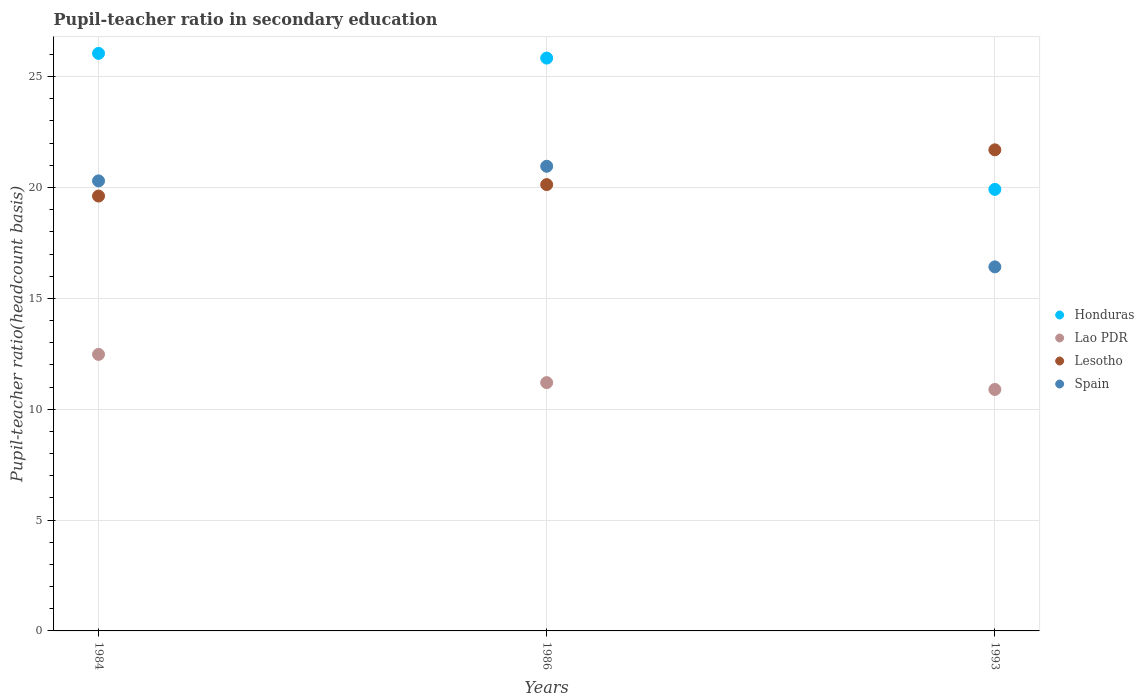How many different coloured dotlines are there?
Make the answer very short. 4. Is the number of dotlines equal to the number of legend labels?
Give a very brief answer. Yes. What is the pupil-teacher ratio in secondary education in Spain in 1984?
Provide a short and direct response. 20.3. Across all years, what is the maximum pupil-teacher ratio in secondary education in Spain?
Make the answer very short. 20.96. Across all years, what is the minimum pupil-teacher ratio in secondary education in Spain?
Offer a terse response. 16.42. In which year was the pupil-teacher ratio in secondary education in Honduras maximum?
Offer a very short reply. 1984. What is the total pupil-teacher ratio in secondary education in Lesotho in the graph?
Give a very brief answer. 61.45. What is the difference between the pupil-teacher ratio in secondary education in Lesotho in 1984 and that in 1986?
Your response must be concise. -0.52. What is the difference between the pupil-teacher ratio in secondary education in Honduras in 1993 and the pupil-teacher ratio in secondary education in Lao PDR in 1986?
Your answer should be compact. 8.72. What is the average pupil-teacher ratio in secondary education in Lao PDR per year?
Offer a very short reply. 11.52. In the year 1993, what is the difference between the pupil-teacher ratio in secondary education in Honduras and pupil-teacher ratio in secondary education in Lao PDR?
Your response must be concise. 9.02. In how many years, is the pupil-teacher ratio in secondary education in Lesotho greater than 18?
Offer a terse response. 3. What is the ratio of the pupil-teacher ratio in secondary education in Honduras in 1984 to that in 1993?
Give a very brief answer. 1.31. Is the pupil-teacher ratio in secondary education in Lao PDR in 1986 less than that in 1993?
Your answer should be compact. No. What is the difference between the highest and the second highest pupil-teacher ratio in secondary education in Honduras?
Give a very brief answer. 0.21. What is the difference between the highest and the lowest pupil-teacher ratio in secondary education in Spain?
Ensure brevity in your answer.  4.54. In how many years, is the pupil-teacher ratio in secondary education in Honduras greater than the average pupil-teacher ratio in secondary education in Honduras taken over all years?
Make the answer very short. 2. Is it the case that in every year, the sum of the pupil-teacher ratio in secondary education in Lesotho and pupil-teacher ratio in secondary education in Spain  is greater than the sum of pupil-teacher ratio in secondary education in Lao PDR and pupil-teacher ratio in secondary education in Honduras?
Your answer should be very brief. Yes. Is it the case that in every year, the sum of the pupil-teacher ratio in secondary education in Lesotho and pupil-teacher ratio in secondary education in Lao PDR  is greater than the pupil-teacher ratio in secondary education in Honduras?
Give a very brief answer. Yes. Is the pupil-teacher ratio in secondary education in Lesotho strictly less than the pupil-teacher ratio in secondary education in Lao PDR over the years?
Keep it short and to the point. No. How many dotlines are there?
Your answer should be very brief. 4. What is the difference between two consecutive major ticks on the Y-axis?
Keep it short and to the point. 5. Does the graph contain grids?
Your answer should be compact. Yes. Where does the legend appear in the graph?
Your answer should be compact. Center right. How are the legend labels stacked?
Make the answer very short. Vertical. What is the title of the graph?
Offer a very short reply. Pupil-teacher ratio in secondary education. Does "Hong Kong" appear as one of the legend labels in the graph?
Provide a succinct answer. No. What is the label or title of the X-axis?
Provide a succinct answer. Years. What is the label or title of the Y-axis?
Make the answer very short. Pupil-teacher ratio(headcount basis). What is the Pupil-teacher ratio(headcount basis) of Honduras in 1984?
Your answer should be compact. 26.05. What is the Pupil-teacher ratio(headcount basis) in Lao PDR in 1984?
Your answer should be compact. 12.47. What is the Pupil-teacher ratio(headcount basis) of Lesotho in 1984?
Your answer should be very brief. 19.61. What is the Pupil-teacher ratio(headcount basis) of Spain in 1984?
Ensure brevity in your answer.  20.3. What is the Pupil-teacher ratio(headcount basis) in Honduras in 1986?
Offer a terse response. 25.84. What is the Pupil-teacher ratio(headcount basis) of Lao PDR in 1986?
Offer a very short reply. 11.2. What is the Pupil-teacher ratio(headcount basis) of Lesotho in 1986?
Provide a succinct answer. 20.13. What is the Pupil-teacher ratio(headcount basis) of Spain in 1986?
Make the answer very short. 20.96. What is the Pupil-teacher ratio(headcount basis) of Honduras in 1993?
Your answer should be very brief. 19.91. What is the Pupil-teacher ratio(headcount basis) of Lao PDR in 1993?
Provide a succinct answer. 10.89. What is the Pupil-teacher ratio(headcount basis) of Lesotho in 1993?
Offer a very short reply. 21.7. What is the Pupil-teacher ratio(headcount basis) of Spain in 1993?
Ensure brevity in your answer.  16.42. Across all years, what is the maximum Pupil-teacher ratio(headcount basis) of Honduras?
Provide a succinct answer. 26.05. Across all years, what is the maximum Pupil-teacher ratio(headcount basis) of Lao PDR?
Keep it short and to the point. 12.47. Across all years, what is the maximum Pupil-teacher ratio(headcount basis) of Lesotho?
Your response must be concise. 21.7. Across all years, what is the maximum Pupil-teacher ratio(headcount basis) in Spain?
Provide a succinct answer. 20.96. Across all years, what is the minimum Pupil-teacher ratio(headcount basis) of Honduras?
Offer a very short reply. 19.91. Across all years, what is the minimum Pupil-teacher ratio(headcount basis) of Lao PDR?
Ensure brevity in your answer.  10.89. Across all years, what is the minimum Pupil-teacher ratio(headcount basis) in Lesotho?
Your answer should be very brief. 19.61. Across all years, what is the minimum Pupil-teacher ratio(headcount basis) in Spain?
Give a very brief answer. 16.42. What is the total Pupil-teacher ratio(headcount basis) in Honduras in the graph?
Offer a terse response. 71.8. What is the total Pupil-teacher ratio(headcount basis) of Lao PDR in the graph?
Ensure brevity in your answer.  34.56. What is the total Pupil-teacher ratio(headcount basis) of Lesotho in the graph?
Provide a succinct answer. 61.45. What is the total Pupil-teacher ratio(headcount basis) in Spain in the graph?
Your answer should be compact. 57.68. What is the difference between the Pupil-teacher ratio(headcount basis) of Honduras in 1984 and that in 1986?
Your answer should be compact. 0.21. What is the difference between the Pupil-teacher ratio(headcount basis) in Lao PDR in 1984 and that in 1986?
Offer a terse response. 1.27. What is the difference between the Pupil-teacher ratio(headcount basis) of Lesotho in 1984 and that in 1986?
Provide a succinct answer. -0.52. What is the difference between the Pupil-teacher ratio(headcount basis) in Spain in 1984 and that in 1986?
Your response must be concise. -0.66. What is the difference between the Pupil-teacher ratio(headcount basis) of Honduras in 1984 and that in 1993?
Offer a very short reply. 6.13. What is the difference between the Pupil-teacher ratio(headcount basis) of Lao PDR in 1984 and that in 1993?
Offer a terse response. 1.58. What is the difference between the Pupil-teacher ratio(headcount basis) of Lesotho in 1984 and that in 1993?
Provide a short and direct response. -2.08. What is the difference between the Pupil-teacher ratio(headcount basis) of Spain in 1984 and that in 1993?
Offer a very short reply. 3.88. What is the difference between the Pupil-teacher ratio(headcount basis) of Honduras in 1986 and that in 1993?
Offer a terse response. 5.92. What is the difference between the Pupil-teacher ratio(headcount basis) of Lao PDR in 1986 and that in 1993?
Your answer should be very brief. 0.31. What is the difference between the Pupil-teacher ratio(headcount basis) in Lesotho in 1986 and that in 1993?
Ensure brevity in your answer.  -1.57. What is the difference between the Pupil-teacher ratio(headcount basis) in Spain in 1986 and that in 1993?
Your response must be concise. 4.54. What is the difference between the Pupil-teacher ratio(headcount basis) of Honduras in 1984 and the Pupil-teacher ratio(headcount basis) of Lao PDR in 1986?
Make the answer very short. 14.85. What is the difference between the Pupil-teacher ratio(headcount basis) of Honduras in 1984 and the Pupil-teacher ratio(headcount basis) of Lesotho in 1986?
Keep it short and to the point. 5.92. What is the difference between the Pupil-teacher ratio(headcount basis) of Honduras in 1984 and the Pupil-teacher ratio(headcount basis) of Spain in 1986?
Keep it short and to the point. 5.09. What is the difference between the Pupil-teacher ratio(headcount basis) of Lao PDR in 1984 and the Pupil-teacher ratio(headcount basis) of Lesotho in 1986?
Offer a terse response. -7.66. What is the difference between the Pupil-teacher ratio(headcount basis) of Lao PDR in 1984 and the Pupil-teacher ratio(headcount basis) of Spain in 1986?
Provide a short and direct response. -8.48. What is the difference between the Pupil-teacher ratio(headcount basis) of Lesotho in 1984 and the Pupil-teacher ratio(headcount basis) of Spain in 1986?
Your answer should be very brief. -1.34. What is the difference between the Pupil-teacher ratio(headcount basis) of Honduras in 1984 and the Pupil-teacher ratio(headcount basis) of Lao PDR in 1993?
Keep it short and to the point. 15.16. What is the difference between the Pupil-teacher ratio(headcount basis) in Honduras in 1984 and the Pupil-teacher ratio(headcount basis) in Lesotho in 1993?
Offer a terse response. 4.35. What is the difference between the Pupil-teacher ratio(headcount basis) of Honduras in 1984 and the Pupil-teacher ratio(headcount basis) of Spain in 1993?
Your response must be concise. 9.63. What is the difference between the Pupil-teacher ratio(headcount basis) of Lao PDR in 1984 and the Pupil-teacher ratio(headcount basis) of Lesotho in 1993?
Your answer should be compact. -9.23. What is the difference between the Pupil-teacher ratio(headcount basis) of Lao PDR in 1984 and the Pupil-teacher ratio(headcount basis) of Spain in 1993?
Make the answer very short. -3.95. What is the difference between the Pupil-teacher ratio(headcount basis) in Lesotho in 1984 and the Pupil-teacher ratio(headcount basis) in Spain in 1993?
Give a very brief answer. 3.19. What is the difference between the Pupil-teacher ratio(headcount basis) of Honduras in 1986 and the Pupil-teacher ratio(headcount basis) of Lao PDR in 1993?
Keep it short and to the point. 14.95. What is the difference between the Pupil-teacher ratio(headcount basis) of Honduras in 1986 and the Pupil-teacher ratio(headcount basis) of Lesotho in 1993?
Give a very brief answer. 4.14. What is the difference between the Pupil-teacher ratio(headcount basis) of Honduras in 1986 and the Pupil-teacher ratio(headcount basis) of Spain in 1993?
Provide a succinct answer. 9.42. What is the difference between the Pupil-teacher ratio(headcount basis) in Lao PDR in 1986 and the Pupil-teacher ratio(headcount basis) in Lesotho in 1993?
Keep it short and to the point. -10.5. What is the difference between the Pupil-teacher ratio(headcount basis) in Lao PDR in 1986 and the Pupil-teacher ratio(headcount basis) in Spain in 1993?
Offer a very short reply. -5.22. What is the difference between the Pupil-teacher ratio(headcount basis) in Lesotho in 1986 and the Pupil-teacher ratio(headcount basis) in Spain in 1993?
Your response must be concise. 3.71. What is the average Pupil-teacher ratio(headcount basis) in Honduras per year?
Your response must be concise. 23.93. What is the average Pupil-teacher ratio(headcount basis) in Lao PDR per year?
Provide a succinct answer. 11.52. What is the average Pupil-teacher ratio(headcount basis) of Lesotho per year?
Provide a succinct answer. 20.48. What is the average Pupil-teacher ratio(headcount basis) of Spain per year?
Make the answer very short. 19.23. In the year 1984, what is the difference between the Pupil-teacher ratio(headcount basis) in Honduras and Pupil-teacher ratio(headcount basis) in Lao PDR?
Provide a succinct answer. 13.58. In the year 1984, what is the difference between the Pupil-teacher ratio(headcount basis) of Honduras and Pupil-teacher ratio(headcount basis) of Lesotho?
Your response must be concise. 6.44. In the year 1984, what is the difference between the Pupil-teacher ratio(headcount basis) in Honduras and Pupil-teacher ratio(headcount basis) in Spain?
Keep it short and to the point. 5.75. In the year 1984, what is the difference between the Pupil-teacher ratio(headcount basis) in Lao PDR and Pupil-teacher ratio(headcount basis) in Lesotho?
Offer a very short reply. -7.14. In the year 1984, what is the difference between the Pupil-teacher ratio(headcount basis) in Lao PDR and Pupil-teacher ratio(headcount basis) in Spain?
Offer a terse response. -7.83. In the year 1984, what is the difference between the Pupil-teacher ratio(headcount basis) of Lesotho and Pupil-teacher ratio(headcount basis) of Spain?
Give a very brief answer. -0.68. In the year 1986, what is the difference between the Pupil-teacher ratio(headcount basis) of Honduras and Pupil-teacher ratio(headcount basis) of Lao PDR?
Give a very brief answer. 14.64. In the year 1986, what is the difference between the Pupil-teacher ratio(headcount basis) in Honduras and Pupil-teacher ratio(headcount basis) in Lesotho?
Your response must be concise. 5.71. In the year 1986, what is the difference between the Pupil-teacher ratio(headcount basis) of Honduras and Pupil-teacher ratio(headcount basis) of Spain?
Offer a very short reply. 4.88. In the year 1986, what is the difference between the Pupil-teacher ratio(headcount basis) of Lao PDR and Pupil-teacher ratio(headcount basis) of Lesotho?
Keep it short and to the point. -8.93. In the year 1986, what is the difference between the Pupil-teacher ratio(headcount basis) of Lao PDR and Pupil-teacher ratio(headcount basis) of Spain?
Your answer should be compact. -9.76. In the year 1986, what is the difference between the Pupil-teacher ratio(headcount basis) in Lesotho and Pupil-teacher ratio(headcount basis) in Spain?
Provide a succinct answer. -0.83. In the year 1993, what is the difference between the Pupil-teacher ratio(headcount basis) of Honduras and Pupil-teacher ratio(headcount basis) of Lao PDR?
Your answer should be very brief. 9.02. In the year 1993, what is the difference between the Pupil-teacher ratio(headcount basis) in Honduras and Pupil-teacher ratio(headcount basis) in Lesotho?
Offer a terse response. -1.78. In the year 1993, what is the difference between the Pupil-teacher ratio(headcount basis) in Honduras and Pupil-teacher ratio(headcount basis) in Spain?
Offer a very short reply. 3.49. In the year 1993, what is the difference between the Pupil-teacher ratio(headcount basis) in Lao PDR and Pupil-teacher ratio(headcount basis) in Lesotho?
Give a very brief answer. -10.81. In the year 1993, what is the difference between the Pupil-teacher ratio(headcount basis) in Lao PDR and Pupil-teacher ratio(headcount basis) in Spain?
Keep it short and to the point. -5.53. In the year 1993, what is the difference between the Pupil-teacher ratio(headcount basis) of Lesotho and Pupil-teacher ratio(headcount basis) of Spain?
Keep it short and to the point. 5.28. What is the ratio of the Pupil-teacher ratio(headcount basis) in Honduras in 1984 to that in 1986?
Offer a terse response. 1.01. What is the ratio of the Pupil-teacher ratio(headcount basis) in Lao PDR in 1984 to that in 1986?
Provide a short and direct response. 1.11. What is the ratio of the Pupil-teacher ratio(headcount basis) in Lesotho in 1984 to that in 1986?
Offer a terse response. 0.97. What is the ratio of the Pupil-teacher ratio(headcount basis) of Spain in 1984 to that in 1986?
Provide a short and direct response. 0.97. What is the ratio of the Pupil-teacher ratio(headcount basis) in Honduras in 1984 to that in 1993?
Keep it short and to the point. 1.31. What is the ratio of the Pupil-teacher ratio(headcount basis) of Lao PDR in 1984 to that in 1993?
Your answer should be compact. 1.15. What is the ratio of the Pupil-teacher ratio(headcount basis) in Lesotho in 1984 to that in 1993?
Give a very brief answer. 0.9. What is the ratio of the Pupil-teacher ratio(headcount basis) of Spain in 1984 to that in 1993?
Offer a very short reply. 1.24. What is the ratio of the Pupil-teacher ratio(headcount basis) of Honduras in 1986 to that in 1993?
Keep it short and to the point. 1.3. What is the ratio of the Pupil-teacher ratio(headcount basis) in Lao PDR in 1986 to that in 1993?
Your answer should be compact. 1.03. What is the ratio of the Pupil-teacher ratio(headcount basis) in Lesotho in 1986 to that in 1993?
Offer a very short reply. 0.93. What is the ratio of the Pupil-teacher ratio(headcount basis) in Spain in 1986 to that in 1993?
Ensure brevity in your answer.  1.28. What is the difference between the highest and the second highest Pupil-teacher ratio(headcount basis) of Honduras?
Your answer should be compact. 0.21. What is the difference between the highest and the second highest Pupil-teacher ratio(headcount basis) of Lao PDR?
Your answer should be compact. 1.27. What is the difference between the highest and the second highest Pupil-teacher ratio(headcount basis) of Lesotho?
Your answer should be very brief. 1.57. What is the difference between the highest and the second highest Pupil-teacher ratio(headcount basis) of Spain?
Keep it short and to the point. 0.66. What is the difference between the highest and the lowest Pupil-teacher ratio(headcount basis) of Honduras?
Offer a very short reply. 6.13. What is the difference between the highest and the lowest Pupil-teacher ratio(headcount basis) in Lao PDR?
Make the answer very short. 1.58. What is the difference between the highest and the lowest Pupil-teacher ratio(headcount basis) in Lesotho?
Ensure brevity in your answer.  2.08. What is the difference between the highest and the lowest Pupil-teacher ratio(headcount basis) of Spain?
Provide a succinct answer. 4.54. 